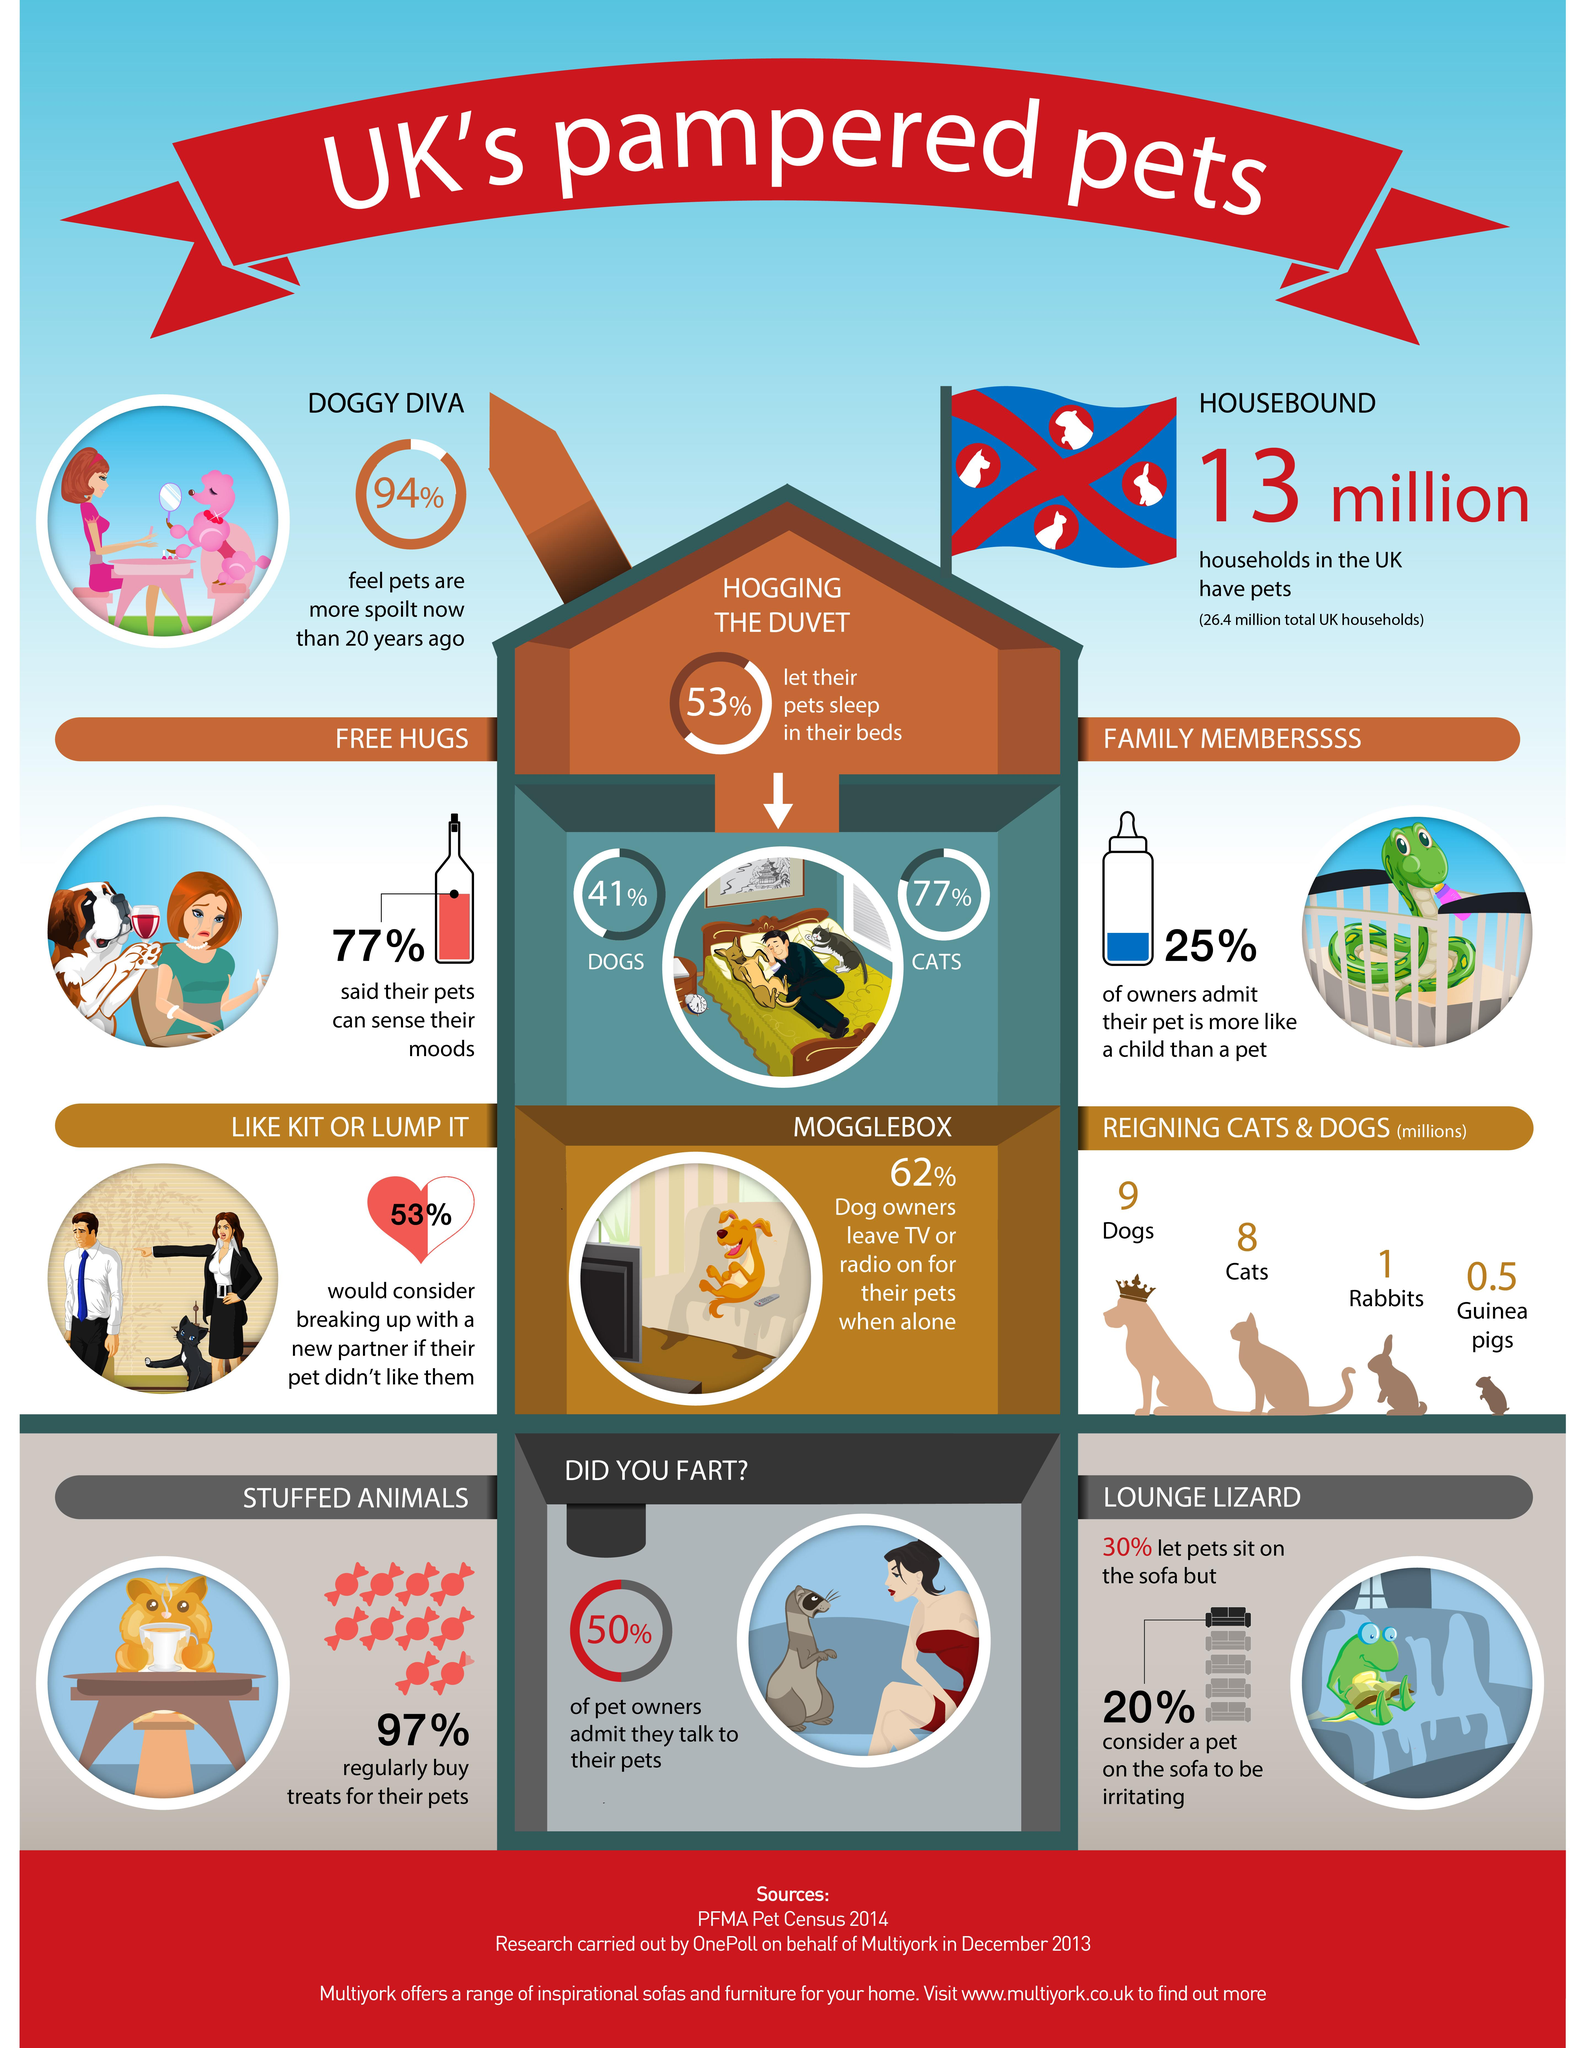Point out several critical features in this image. According to a survey conducted in the UK, half of all pet owners admitted that they do not communicate with their pets. According to recent estimates, there are approximately 8 million reigning cats in the United Kingdom. According to a recent survey, only 3% of pet owners in the UK do not buy treats for their pets regularly. According to a survey of pet owners in the UK, a significant majority, 77%, believe that their pets can sense their moods. There are approximately 9 million reigning dogs in the United Kingdom. 